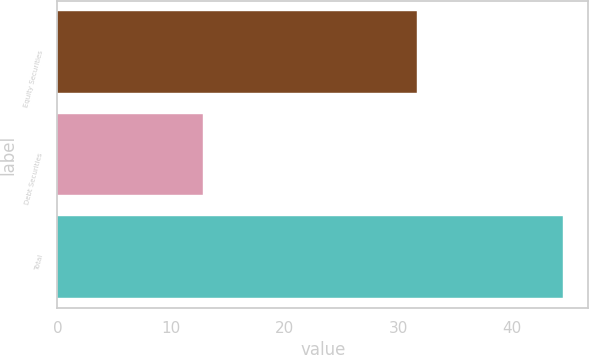Convert chart. <chart><loc_0><loc_0><loc_500><loc_500><bar_chart><fcel>Equity Securities<fcel>Debt Securities<fcel>Total<nl><fcel>31.7<fcel>12.8<fcel>44.5<nl></chart> 